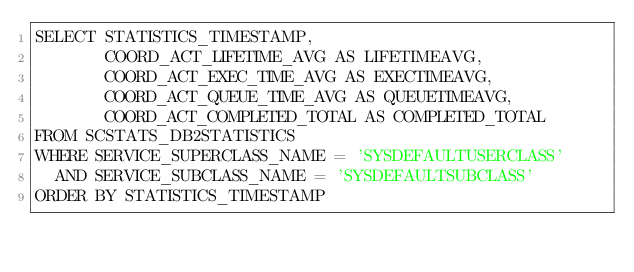Convert code to text. <code><loc_0><loc_0><loc_500><loc_500><_SQL_>SELECT STATISTICS_TIMESTAMP,
       COORD_ACT_LIFETIME_AVG AS LIFETIMEAVG,
       COORD_ACT_EXEC_TIME_AVG AS EXECTIMEAVG,
       COORD_ACT_QUEUE_TIME_AVG AS QUEUETIMEAVG,
       COORD_ACT_COMPLETED_TOTAL AS COMPLETED_TOTAL
FROM SCSTATS_DB2STATISTICS
WHERE SERVICE_SUPERCLASS_NAME = 'SYSDEFAULTUSERCLASS'
  AND SERVICE_SUBCLASS_NAME = 'SYSDEFAULTSUBCLASS'
ORDER BY STATISTICS_TIMESTAMP</code> 